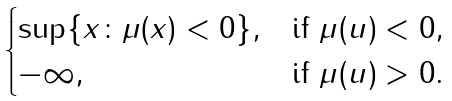Convert formula to latex. <formula><loc_0><loc_0><loc_500><loc_500>\begin{cases} \sup \{ x \colon \mu ( x ) < 0 \} , & \text {if $\mu(u)<0$} , \\ - \infty , & \text {if $\mu(u)>0$} . \end{cases}</formula> 